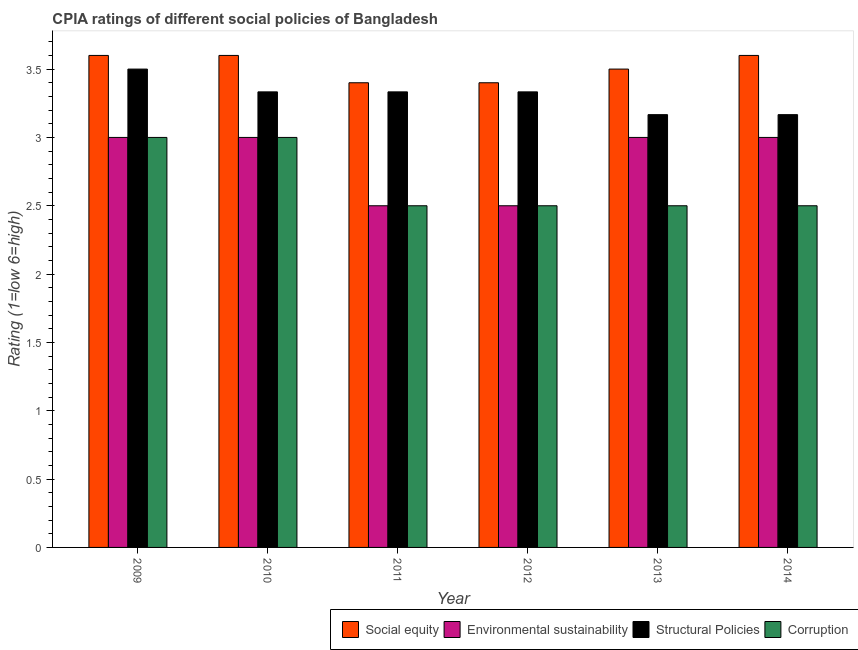Are the number of bars per tick equal to the number of legend labels?
Provide a succinct answer. Yes. Are the number of bars on each tick of the X-axis equal?
Ensure brevity in your answer.  Yes. How many bars are there on the 3rd tick from the right?
Keep it short and to the point. 4. What is the label of the 1st group of bars from the left?
Keep it short and to the point. 2009. In how many cases, is the number of bars for a given year not equal to the number of legend labels?
Keep it short and to the point. 0. In which year was the cpia rating of corruption maximum?
Offer a very short reply. 2009. In which year was the cpia rating of environmental sustainability minimum?
Provide a succinct answer. 2011. What is the total cpia rating of environmental sustainability in the graph?
Ensure brevity in your answer.  17. What is the average cpia rating of social equity per year?
Give a very brief answer. 3.52. In the year 2012, what is the difference between the cpia rating of environmental sustainability and cpia rating of corruption?
Offer a terse response. 0. What is the ratio of the cpia rating of environmental sustainability in 2009 to that in 2011?
Give a very brief answer. 1.2. Is the difference between the cpia rating of social equity in 2009 and 2012 greater than the difference between the cpia rating of structural policies in 2009 and 2012?
Provide a succinct answer. No. What is the difference between the highest and the second highest cpia rating of corruption?
Your answer should be compact. 0. What is the difference between the highest and the lowest cpia rating of structural policies?
Provide a short and direct response. 0.33. Is the sum of the cpia rating of corruption in 2009 and 2012 greater than the maximum cpia rating of environmental sustainability across all years?
Your answer should be compact. Yes. Is it the case that in every year, the sum of the cpia rating of corruption and cpia rating of structural policies is greater than the sum of cpia rating of environmental sustainability and cpia rating of social equity?
Offer a terse response. No. What does the 2nd bar from the left in 2013 represents?
Your answer should be compact. Environmental sustainability. What does the 2nd bar from the right in 2010 represents?
Ensure brevity in your answer.  Structural Policies. How many bars are there?
Your answer should be compact. 24. What is the difference between two consecutive major ticks on the Y-axis?
Offer a terse response. 0.5. Are the values on the major ticks of Y-axis written in scientific E-notation?
Offer a terse response. No. Does the graph contain any zero values?
Ensure brevity in your answer.  No. Does the graph contain grids?
Your answer should be compact. No. Where does the legend appear in the graph?
Offer a terse response. Bottom right. How many legend labels are there?
Give a very brief answer. 4. How are the legend labels stacked?
Offer a very short reply. Horizontal. What is the title of the graph?
Provide a short and direct response. CPIA ratings of different social policies of Bangladesh. What is the label or title of the Y-axis?
Make the answer very short. Rating (1=low 6=high). What is the Rating (1=low 6=high) of Social equity in 2009?
Offer a very short reply. 3.6. What is the Rating (1=low 6=high) in Environmental sustainability in 2010?
Your answer should be compact. 3. What is the Rating (1=low 6=high) in Structural Policies in 2010?
Your answer should be compact. 3.33. What is the Rating (1=low 6=high) in Corruption in 2010?
Offer a terse response. 3. What is the Rating (1=low 6=high) of Environmental sustainability in 2011?
Offer a terse response. 2.5. What is the Rating (1=low 6=high) in Structural Policies in 2011?
Your answer should be very brief. 3.33. What is the Rating (1=low 6=high) in Social equity in 2012?
Offer a terse response. 3.4. What is the Rating (1=low 6=high) of Structural Policies in 2012?
Offer a very short reply. 3.33. What is the Rating (1=low 6=high) of Structural Policies in 2013?
Provide a succinct answer. 3.17. What is the Rating (1=low 6=high) in Corruption in 2013?
Provide a short and direct response. 2.5. What is the Rating (1=low 6=high) in Structural Policies in 2014?
Provide a short and direct response. 3.17. Across all years, what is the maximum Rating (1=low 6=high) of Corruption?
Ensure brevity in your answer.  3. Across all years, what is the minimum Rating (1=low 6=high) of Structural Policies?
Your answer should be very brief. 3.17. What is the total Rating (1=low 6=high) in Social equity in the graph?
Provide a succinct answer. 21.1. What is the total Rating (1=low 6=high) in Environmental sustainability in the graph?
Offer a very short reply. 17. What is the total Rating (1=low 6=high) of Structural Policies in the graph?
Offer a terse response. 19.83. What is the total Rating (1=low 6=high) of Corruption in the graph?
Keep it short and to the point. 16. What is the difference between the Rating (1=low 6=high) of Social equity in 2009 and that in 2010?
Offer a very short reply. 0. What is the difference between the Rating (1=low 6=high) of Social equity in 2009 and that in 2011?
Make the answer very short. 0.2. What is the difference between the Rating (1=low 6=high) of Structural Policies in 2009 and that in 2011?
Your answer should be very brief. 0.17. What is the difference between the Rating (1=low 6=high) of Environmental sustainability in 2009 and that in 2012?
Provide a succinct answer. 0.5. What is the difference between the Rating (1=low 6=high) in Structural Policies in 2009 and that in 2012?
Your answer should be compact. 0.17. What is the difference between the Rating (1=low 6=high) of Social equity in 2009 and that in 2013?
Give a very brief answer. 0.1. What is the difference between the Rating (1=low 6=high) of Structural Policies in 2009 and that in 2013?
Your response must be concise. 0.33. What is the difference between the Rating (1=low 6=high) of Corruption in 2009 and that in 2013?
Your answer should be compact. 0.5. What is the difference between the Rating (1=low 6=high) of Social equity in 2009 and that in 2014?
Offer a very short reply. 0. What is the difference between the Rating (1=low 6=high) of Corruption in 2009 and that in 2014?
Provide a succinct answer. 0.5. What is the difference between the Rating (1=low 6=high) of Social equity in 2010 and that in 2012?
Your answer should be very brief. 0.2. What is the difference between the Rating (1=low 6=high) of Environmental sustainability in 2010 and that in 2012?
Your answer should be very brief. 0.5. What is the difference between the Rating (1=low 6=high) in Corruption in 2010 and that in 2012?
Provide a succinct answer. 0.5. What is the difference between the Rating (1=low 6=high) in Environmental sustainability in 2010 and that in 2014?
Make the answer very short. 0. What is the difference between the Rating (1=low 6=high) of Environmental sustainability in 2011 and that in 2012?
Offer a very short reply. 0. What is the difference between the Rating (1=low 6=high) in Social equity in 2011 and that in 2013?
Ensure brevity in your answer.  -0.1. What is the difference between the Rating (1=low 6=high) of Environmental sustainability in 2011 and that in 2013?
Provide a short and direct response. -0.5. What is the difference between the Rating (1=low 6=high) in Corruption in 2011 and that in 2013?
Offer a very short reply. 0. What is the difference between the Rating (1=low 6=high) in Structural Policies in 2011 and that in 2014?
Your answer should be compact. 0.17. What is the difference between the Rating (1=low 6=high) in Structural Policies in 2012 and that in 2013?
Keep it short and to the point. 0.17. What is the difference between the Rating (1=low 6=high) of Corruption in 2012 and that in 2013?
Make the answer very short. 0. What is the difference between the Rating (1=low 6=high) of Environmental sustainability in 2012 and that in 2014?
Your response must be concise. -0.5. What is the difference between the Rating (1=low 6=high) in Environmental sustainability in 2013 and that in 2014?
Give a very brief answer. 0. What is the difference between the Rating (1=low 6=high) of Structural Policies in 2013 and that in 2014?
Give a very brief answer. -0. What is the difference between the Rating (1=low 6=high) in Social equity in 2009 and the Rating (1=low 6=high) in Structural Policies in 2010?
Your answer should be very brief. 0.27. What is the difference between the Rating (1=low 6=high) in Environmental sustainability in 2009 and the Rating (1=low 6=high) in Corruption in 2010?
Ensure brevity in your answer.  0. What is the difference between the Rating (1=low 6=high) in Structural Policies in 2009 and the Rating (1=low 6=high) in Corruption in 2010?
Ensure brevity in your answer.  0.5. What is the difference between the Rating (1=low 6=high) in Social equity in 2009 and the Rating (1=low 6=high) in Environmental sustainability in 2011?
Keep it short and to the point. 1.1. What is the difference between the Rating (1=low 6=high) of Social equity in 2009 and the Rating (1=low 6=high) of Structural Policies in 2011?
Offer a very short reply. 0.27. What is the difference between the Rating (1=low 6=high) in Environmental sustainability in 2009 and the Rating (1=low 6=high) in Structural Policies in 2011?
Ensure brevity in your answer.  -0.33. What is the difference between the Rating (1=low 6=high) in Structural Policies in 2009 and the Rating (1=low 6=high) in Corruption in 2011?
Give a very brief answer. 1. What is the difference between the Rating (1=low 6=high) of Social equity in 2009 and the Rating (1=low 6=high) of Environmental sustainability in 2012?
Your answer should be compact. 1.1. What is the difference between the Rating (1=low 6=high) of Social equity in 2009 and the Rating (1=low 6=high) of Structural Policies in 2012?
Ensure brevity in your answer.  0.27. What is the difference between the Rating (1=low 6=high) of Environmental sustainability in 2009 and the Rating (1=low 6=high) of Structural Policies in 2012?
Ensure brevity in your answer.  -0.33. What is the difference between the Rating (1=low 6=high) in Structural Policies in 2009 and the Rating (1=low 6=high) in Corruption in 2012?
Give a very brief answer. 1. What is the difference between the Rating (1=low 6=high) of Social equity in 2009 and the Rating (1=low 6=high) of Structural Policies in 2013?
Your answer should be compact. 0.43. What is the difference between the Rating (1=low 6=high) of Social equity in 2009 and the Rating (1=low 6=high) of Corruption in 2013?
Offer a very short reply. 1.1. What is the difference between the Rating (1=low 6=high) in Environmental sustainability in 2009 and the Rating (1=low 6=high) in Structural Policies in 2013?
Give a very brief answer. -0.17. What is the difference between the Rating (1=low 6=high) in Environmental sustainability in 2009 and the Rating (1=low 6=high) in Corruption in 2013?
Keep it short and to the point. 0.5. What is the difference between the Rating (1=low 6=high) of Social equity in 2009 and the Rating (1=low 6=high) of Environmental sustainability in 2014?
Your answer should be compact. 0.6. What is the difference between the Rating (1=low 6=high) in Social equity in 2009 and the Rating (1=low 6=high) in Structural Policies in 2014?
Make the answer very short. 0.43. What is the difference between the Rating (1=low 6=high) of Social equity in 2009 and the Rating (1=low 6=high) of Corruption in 2014?
Ensure brevity in your answer.  1.1. What is the difference between the Rating (1=low 6=high) in Environmental sustainability in 2009 and the Rating (1=low 6=high) in Structural Policies in 2014?
Your answer should be very brief. -0.17. What is the difference between the Rating (1=low 6=high) of Structural Policies in 2009 and the Rating (1=low 6=high) of Corruption in 2014?
Make the answer very short. 1. What is the difference between the Rating (1=low 6=high) of Social equity in 2010 and the Rating (1=low 6=high) of Environmental sustainability in 2011?
Offer a terse response. 1.1. What is the difference between the Rating (1=low 6=high) of Social equity in 2010 and the Rating (1=low 6=high) of Structural Policies in 2011?
Give a very brief answer. 0.27. What is the difference between the Rating (1=low 6=high) in Social equity in 2010 and the Rating (1=low 6=high) in Corruption in 2011?
Give a very brief answer. 1.1. What is the difference between the Rating (1=low 6=high) in Environmental sustainability in 2010 and the Rating (1=low 6=high) in Corruption in 2011?
Your answer should be compact. 0.5. What is the difference between the Rating (1=low 6=high) of Structural Policies in 2010 and the Rating (1=low 6=high) of Corruption in 2011?
Offer a very short reply. 0.83. What is the difference between the Rating (1=low 6=high) of Social equity in 2010 and the Rating (1=low 6=high) of Environmental sustainability in 2012?
Your response must be concise. 1.1. What is the difference between the Rating (1=low 6=high) in Social equity in 2010 and the Rating (1=low 6=high) in Structural Policies in 2012?
Your answer should be very brief. 0.27. What is the difference between the Rating (1=low 6=high) of Environmental sustainability in 2010 and the Rating (1=low 6=high) of Structural Policies in 2012?
Your response must be concise. -0.33. What is the difference between the Rating (1=low 6=high) of Structural Policies in 2010 and the Rating (1=low 6=high) of Corruption in 2012?
Provide a short and direct response. 0.83. What is the difference between the Rating (1=low 6=high) of Social equity in 2010 and the Rating (1=low 6=high) of Environmental sustainability in 2013?
Give a very brief answer. 0.6. What is the difference between the Rating (1=low 6=high) of Social equity in 2010 and the Rating (1=low 6=high) of Structural Policies in 2013?
Keep it short and to the point. 0.43. What is the difference between the Rating (1=low 6=high) in Environmental sustainability in 2010 and the Rating (1=low 6=high) in Corruption in 2013?
Offer a very short reply. 0.5. What is the difference between the Rating (1=low 6=high) in Social equity in 2010 and the Rating (1=low 6=high) in Environmental sustainability in 2014?
Your answer should be compact. 0.6. What is the difference between the Rating (1=low 6=high) of Social equity in 2010 and the Rating (1=low 6=high) of Structural Policies in 2014?
Make the answer very short. 0.43. What is the difference between the Rating (1=low 6=high) of Social equity in 2010 and the Rating (1=low 6=high) of Corruption in 2014?
Provide a short and direct response. 1.1. What is the difference between the Rating (1=low 6=high) in Social equity in 2011 and the Rating (1=low 6=high) in Environmental sustainability in 2012?
Provide a short and direct response. 0.9. What is the difference between the Rating (1=low 6=high) of Social equity in 2011 and the Rating (1=low 6=high) of Structural Policies in 2012?
Your answer should be very brief. 0.07. What is the difference between the Rating (1=low 6=high) of Social equity in 2011 and the Rating (1=low 6=high) of Corruption in 2012?
Ensure brevity in your answer.  0.9. What is the difference between the Rating (1=low 6=high) of Environmental sustainability in 2011 and the Rating (1=low 6=high) of Structural Policies in 2012?
Make the answer very short. -0.83. What is the difference between the Rating (1=low 6=high) in Structural Policies in 2011 and the Rating (1=low 6=high) in Corruption in 2012?
Your answer should be very brief. 0.83. What is the difference between the Rating (1=low 6=high) of Social equity in 2011 and the Rating (1=low 6=high) of Structural Policies in 2013?
Offer a terse response. 0.23. What is the difference between the Rating (1=low 6=high) in Social equity in 2011 and the Rating (1=low 6=high) in Corruption in 2013?
Offer a very short reply. 0.9. What is the difference between the Rating (1=low 6=high) of Environmental sustainability in 2011 and the Rating (1=low 6=high) of Structural Policies in 2013?
Offer a terse response. -0.67. What is the difference between the Rating (1=low 6=high) in Environmental sustainability in 2011 and the Rating (1=low 6=high) in Corruption in 2013?
Keep it short and to the point. 0. What is the difference between the Rating (1=low 6=high) of Structural Policies in 2011 and the Rating (1=low 6=high) of Corruption in 2013?
Provide a succinct answer. 0.83. What is the difference between the Rating (1=low 6=high) in Social equity in 2011 and the Rating (1=low 6=high) in Structural Policies in 2014?
Provide a succinct answer. 0.23. What is the difference between the Rating (1=low 6=high) in Social equity in 2011 and the Rating (1=low 6=high) in Corruption in 2014?
Your answer should be very brief. 0.9. What is the difference between the Rating (1=low 6=high) in Environmental sustainability in 2011 and the Rating (1=low 6=high) in Corruption in 2014?
Your answer should be very brief. 0. What is the difference between the Rating (1=low 6=high) of Social equity in 2012 and the Rating (1=low 6=high) of Structural Policies in 2013?
Provide a short and direct response. 0.23. What is the difference between the Rating (1=low 6=high) of Structural Policies in 2012 and the Rating (1=low 6=high) of Corruption in 2013?
Your response must be concise. 0.83. What is the difference between the Rating (1=low 6=high) in Social equity in 2012 and the Rating (1=low 6=high) in Environmental sustainability in 2014?
Give a very brief answer. 0.4. What is the difference between the Rating (1=low 6=high) of Social equity in 2012 and the Rating (1=low 6=high) of Structural Policies in 2014?
Provide a short and direct response. 0.23. What is the difference between the Rating (1=low 6=high) of Social equity in 2012 and the Rating (1=low 6=high) of Corruption in 2014?
Offer a terse response. 0.9. What is the difference between the Rating (1=low 6=high) in Environmental sustainability in 2012 and the Rating (1=low 6=high) in Structural Policies in 2014?
Your answer should be very brief. -0.67. What is the difference between the Rating (1=low 6=high) in Environmental sustainability in 2012 and the Rating (1=low 6=high) in Corruption in 2014?
Offer a terse response. 0. What is the difference between the Rating (1=low 6=high) of Structural Policies in 2012 and the Rating (1=low 6=high) of Corruption in 2014?
Your answer should be very brief. 0.83. What is the difference between the Rating (1=low 6=high) of Environmental sustainability in 2013 and the Rating (1=low 6=high) of Structural Policies in 2014?
Make the answer very short. -0.17. What is the difference between the Rating (1=low 6=high) in Structural Policies in 2013 and the Rating (1=low 6=high) in Corruption in 2014?
Provide a succinct answer. 0.67. What is the average Rating (1=low 6=high) of Social equity per year?
Your answer should be compact. 3.52. What is the average Rating (1=low 6=high) of Environmental sustainability per year?
Your answer should be very brief. 2.83. What is the average Rating (1=low 6=high) of Structural Policies per year?
Provide a short and direct response. 3.31. What is the average Rating (1=low 6=high) in Corruption per year?
Make the answer very short. 2.67. In the year 2009, what is the difference between the Rating (1=low 6=high) in Social equity and Rating (1=low 6=high) in Environmental sustainability?
Your response must be concise. 0.6. In the year 2009, what is the difference between the Rating (1=low 6=high) in Environmental sustainability and Rating (1=low 6=high) in Corruption?
Provide a short and direct response. 0. In the year 2009, what is the difference between the Rating (1=low 6=high) of Structural Policies and Rating (1=low 6=high) of Corruption?
Offer a terse response. 0.5. In the year 2010, what is the difference between the Rating (1=low 6=high) in Social equity and Rating (1=low 6=high) in Structural Policies?
Your answer should be very brief. 0.27. In the year 2010, what is the difference between the Rating (1=low 6=high) in Social equity and Rating (1=low 6=high) in Corruption?
Keep it short and to the point. 0.6. In the year 2010, what is the difference between the Rating (1=low 6=high) in Environmental sustainability and Rating (1=low 6=high) in Corruption?
Offer a terse response. 0. In the year 2010, what is the difference between the Rating (1=low 6=high) in Structural Policies and Rating (1=low 6=high) in Corruption?
Your answer should be very brief. 0.33. In the year 2011, what is the difference between the Rating (1=low 6=high) in Social equity and Rating (1=low 6=high) in Structural Policies?
Offer a very short reply. 0.07. In the year 2011, what is the difference between the Rating (1=low 6=high) in Environmental sustainability and Rating (1=low 6=high) in Corruption?
Your answer should be compact. 0. In the year 2011, what is the difference between the Rating (1=low 6=high) of Structural Policies and Rating (1=low 6=high) of Corruption?
Give a very brief answer. 0.83. In the year 2012, what is the difference between the Rating (1=low 6=high) of Social equity and Rating (1=low 6=high) of Environmental sustainability?
Your answer should be compact. 0.9. In the year 2012, what is the difference between the Rating (1=low 6=high) of Social equity and Rating (1=low 6=high) of Structural Policies?
Make the answer very short. 0.07. In the year 2012, what is the difference between the Rating (1=low 6=high) of Social equity and Rating (1=low 6=high) of Corruption?
Your answer should be compact. 0.9. In the year 2012, what is the difference between the Rating (1=low 6=high) of Environmental sustainability and Rating (1=low 6=high) of Corruption?
Make the answer very short. 0. In the year 2012, what is the difference between the Rating (1=low 6=high) of Structural Policies and Rating (1=low 6=high) of Corruption?
Your answer should be compact. 0.83. In the year 2013, what is the difference between the Rating (1=low 6=high) of Social equity and Rating (1=low 6=high) of Structural Policies?
Your answer should be very brief. 0.33. In the year 2013, what is the difference between the Rating (1=low 6=high) in Environmental sustainability and Rating (1=low 6=high) in Structural Policies?
Give a very brief answer. -0.17. In the year 2013, what is the difference between the Rating (1=low 6=high) in Environmental sustainability and Rating (1=low 6=high) in Corruption?
Ensure brevity in your answer.  0.5. In the year 2014, what is the difference between the Rating (1=low 6=high) of Social equity and Rating (1=low 6=high) of Environmental sustainability?
Keep it short and to the point. 0.6. In the year 2014, what is the difference between the Rating (1=low 6=high) in Social equity and Rating (1=low 6=high) in Structural Policies?
Your answer should be compact. 0.43. In the year 2014, what is the difference between the Rating (1=low 6=high) of Social equity and Rating (1=low 6=high) of Corruption?
Offer a terse response. 1.1. In the year 2014, what is the difference between the Rating (1=low 6=high) of Environmental sustainability and Rating (1=low 6=high) of Structural Policies?
Ensure brevity in your answer.  -0.17. In the year 2014, what is the difference between the Rating (1=low 6=high) of Environmental sustainability and Rating (1=low 6=high) of Corruption?
Offer a very short reply. 0.5. What is the ratio of the Rating (1=low 6=high) in Social equity in 2009 to that in 2011?
Your answer should be compact. 1.06. What is the ratio of the Rating (1=low 6=high) in Environmental sustainability in 2009 to that in 2011?
Make the answer very short. 1.2. What is the ratio of the Rating (1=low 6=high) in Social equity in 2009 to that in 2012?
Offer a very short reply. 1.06. What is the ratio of the Rating (1=low 6=high) in Environmental sustainability in 2009 to that in 2012?
Make the answer very short. 1.2. What is the ratio of the Rating (1=low 6=high) of Social equity in 2009 to that in 2013?
Provide a succinct answer. 1.03. What is the ratio of the Rating (1=low 6=high) of Environmental sustainability in 2009 to that in 2013?
Offer a terse response. 1. What is the ratio of the Rating (1=low 6=high) of Structural Policies in 2009 to that in 2013?
Provide a succinct answer. 1.11. What is the ratio of the Rating (1=low 6=high) of Environmental sustainability in 2009 to that in 2014?
Your response must be concise. 1. What is the ratio of the Rating (1=low 6=high) in Structural Policies in 2009 to that in 2014?
Offer a very short reply. 1.11. What is the ratio of the Rating (1=low 6=high) of Corruption in 2009 to that in 2014?
Provide a short and direct response. 1.2. What is the ratio of the Rating (1=low 6=high) in Social equity in 2010 to that in 2011?
Offer a very short reply. 1.06. What is the ratio of the Rating (1=low 6=high) in Environmental sustainability in 2010 to that in 2011?
Keep it short and to the point. 1.2. What is the ratio of the Rating (1=low 6=high) in Structural Policies in 2010 to that in 2011?
Ensure brevity in your answer.  1. What is the ratio of the Rating (1=low 6=high) in Corruption in 2010 to that in 2011?
Your answer should be very brief. 1.2. What is the ratio of the Rating (1=low 6=high) of Social equity in 2010 to that in 2012?
Your answer should be compact. 1.06. What is the ratio of the Rating (1=low 6=high) of Environmental sustainability in 2010 to that in 2012?
Offer a very short reply. 1.2. What is the ratio of the Rating (1=low 6=high) in Structural Policies in 2010 to that in 2012?
Your response must be concise. 1. What is the ratio of the Rating (1=low 6=high) of Corruption in 2010 to that in 2012?
Offer a terse response. 1.2. What is the ratio of the Rating (1=low 6=high) of Social equity in 2010 to that in 2013?
Your answer should be very brief. 1.03. What is the ratio of the Rating (1=low 6=high) of Structural Policies in 2010 to that in 2013?
Provide a succinct answer. 1.05. What is the ratio of the Rating (1=low 6=high) of Corruption in 2010 to that in 2013?
Provide a short and direct response. 1.2. What is the ratio of the Rating (1=low 6=high) in Environmental sustainability in 2010 to that in 2014?
Offer a very short reply. 1. What is the ratio of the Rating (1=low 6=high) in Structural Policies in 2010 to that in 2014?
Offer a very short reply. 1.05. What is the ratio of the Rating (1=low 6=high) in Environmental sustainability in 2011 to that in 2012?
Make the answer very short. 1. What is the ratio of the Rating (1=low 6=high) of Social equity in 2011 to that in 2013?
Make the answer very short. 0.97. What is the ratio of the Rating (1=low 6=high) in Environmental sustainability in 2011 to that in 2013?
Offer a terse response. 0.83. What is the ratio of the Rating (1=low 6=high) in Structural Policies in 2011 to that in 2013?
Provide a succinct answer. 1.05. What is the ratio of the Rating (1=low 6=high) of Social equity in 2011 to that in 2014?
Your response must be concise. 0.94. What is the ratio of the Rating (1=low 6=high) in Structural Policies in 2011 to that in 2014?
Offer a very short reply. 1.05. What is the ratio of the Rating (1=low 6=high) in Social equity in 2012 to that in 2013?
Ensure brevity in your answer.  0.97. What is the ratio of the Rating (1=low 6=high) of Structural Policies in 2012 to that in 2013?
Give a very brief answer. 1.05. What is the ratio of the Rating (1=low 6=high) of Social equity in 2012 to that in 2014?
Your response must be concise. 0.94. What is the ratio of the Rating (1=low 6=high) of Structural Policies in 2012 to that in 2014?
Give a very brief answer. 1.05. What is the ratio of the Rating (1=low 6=high) in Social equity in 2013 to that in 2014?
Provide a short and direct response. 0.97. What is the ratio of the Rating (1=low 6=high) of Environmental sustainability in 2013 to that in 2014?
Keep it short and to the point. 1. What is the ratio of the Rating (1=low 6=high) of Corruption in 2013 to that in 2014?
Your answer should be very brief. 1. What is the difference between the highest and the second highest Rating (1=low 6=high) in Social equity?
Your answer should be very brief. 0. What is the difference between the highest and the second highest Rating (1=low 6=high) in Corruption?
Provide a short and direct response. 0. What is the difference between the highest and the lowest Rating (1=low 6=high) in Environmental sustainability?
Your answer should be very brief. 0.5. 